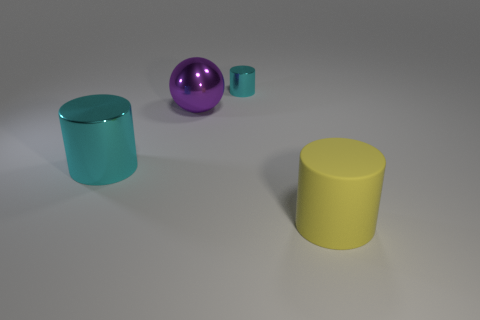Subtract all yellow cylinders. How many cylinders are left? 2 Subtract all gray blocks. How many cyan cylinders are left? 2 Add 2 big brown metal spheres. How many objects exist? 6 Subtract all cyan cylinders. How many cylinders are left? 1 Subtract all spheres. How many objects are left? 3 Subtract 1 cylinders. How many cylinders are left? 2 Subtract all brown cylinders. Subtract all cyan balls. How many cylinders are left? 3 Subtract all large yellow cylinders. Subtract all brown matte balls. How many objects are left? 3 Add 4 large yellow matte cylinders. How many large yellow matte cylinders are left? 5 Add 2 large cyan things. How many large cyan things exist? 3 